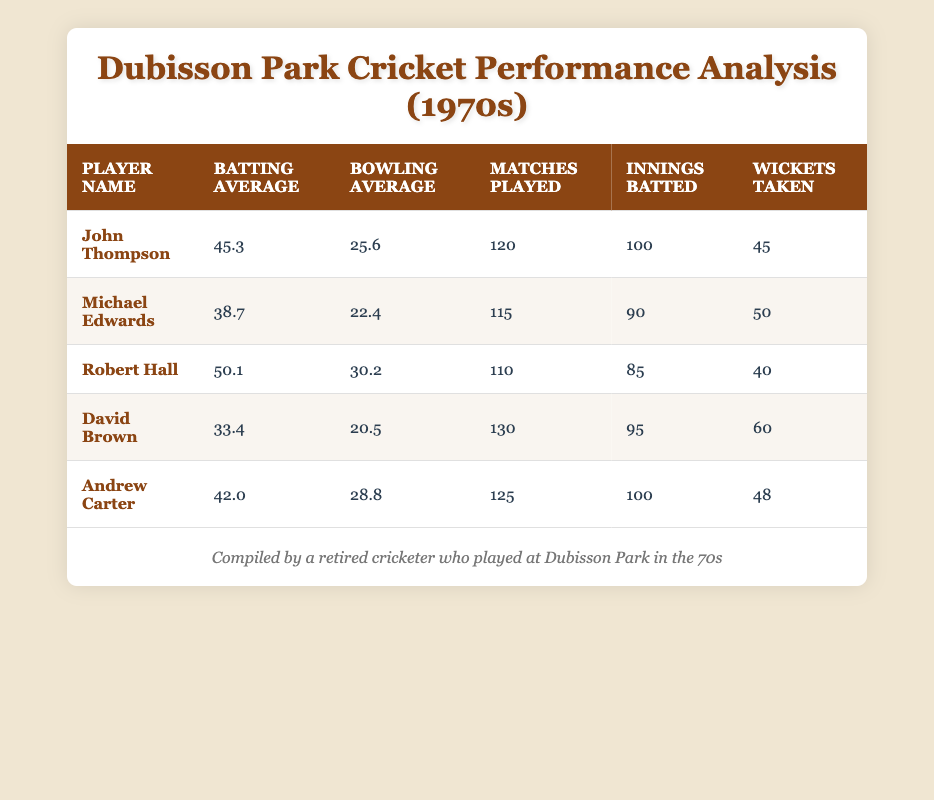What is the highest batting average among the players? The batting averages are: John Thompson (45.3), Michael Edwards (38.7), Robert Hall (50.1), David Brown (33.4), and Andrew Carter (42.0). The highest value is 50.1, which belongs to Robert Hall.
Answer: 50.1 How many matches did David Brown play? The table shows that David Brown played 130 matches.
Answer: 130 Who has the lowest bowling average and what is that average? The bowling averages are: John Thompson (25.6), Michael Edwards (22.4), Robert Hall (30.2), David Brown (20.5), and Andrew Carter (28.8). The lowest value is 20.5, which belongs to David Brown.
Answer: David Brown, 20.5 What is the combined number of wickets taken by Michael Edwards and Andrew Carter? Michael Edwards took 50 wickets, and Andrew Carter took 48 wickets. Summing these gives 50 + 48 = 98 wickets.
Answer: 98 Is Robert Hall's bowling average greater than the average of John Thompson and David Brown? John Thompson has a bowling average of 25.6, and David Brown has 20.5. The average of their bowling averages is (25.6 + 20.5) / 2 = 23.05. Robert Hall's bowling average is 30.2, which is greater than 23.05.
Answer: Yes Which player has the highest wickets taken and how many? The players’ wickets taken are: John Thompson (45), Michael Edwards (50), Robert Hall (40), David Brown (60), and Andrew Carter (48). The highest is 60, achieved by David Brown.
Answer: David Brown, 60 What is the average batting average of all players listed? The batting averages are 45.3, 38.7, 50.1, 33.4, and 42.0. To find the average: (45.3 + 38.7 + 50.1 + 33.4 + 42.0) / 5 = 41.9.
Answer: 41.9 Which player played the most matches, and how many did they play? From the table, David Brown played the most matches, totaling 130.
Answer: David Brown, 130 